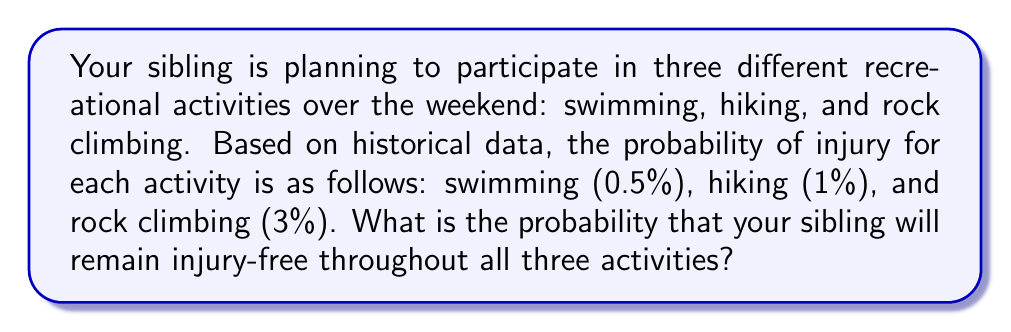Can you solve this math problem? To solve this problem, we need to follow these steps:

1. Identify the probability of staying safe for each activity:
   - Swimming: $1 - 0.005 = 0.995$ or $99.5\%$
   - Hiking: $1 - 0.01 = 0.99$ or $99\%$
   - Rock climbing: $1 - 0.03 = 0.97$ or $97\%$

2. To calculate the probability of remaining injury-free in all three activities, we need to multiply the individual probabilities of staying safe:

   $$P(\text{injury-free}) = P(\text{safe swimming}) \times P(\text{safe hiking}) \times P(\text{safe rock climbing})$$

3. Substituting the values:

   $$P(\text{injury-free}) = 0.995 \times 0.99 \times 0.97$$

4. Calculating the result:

   $$P(\text{injury-free}) = 0.9553965 \approx 0.9554$$

5. Convert to a percentage:

   $$0.9554 \times 100\% = 95.54\%$$

Therefore, the probability that your sibling will remain injury-free throughout all three activities is approximately 95.54%.
Answer: 95.54% 